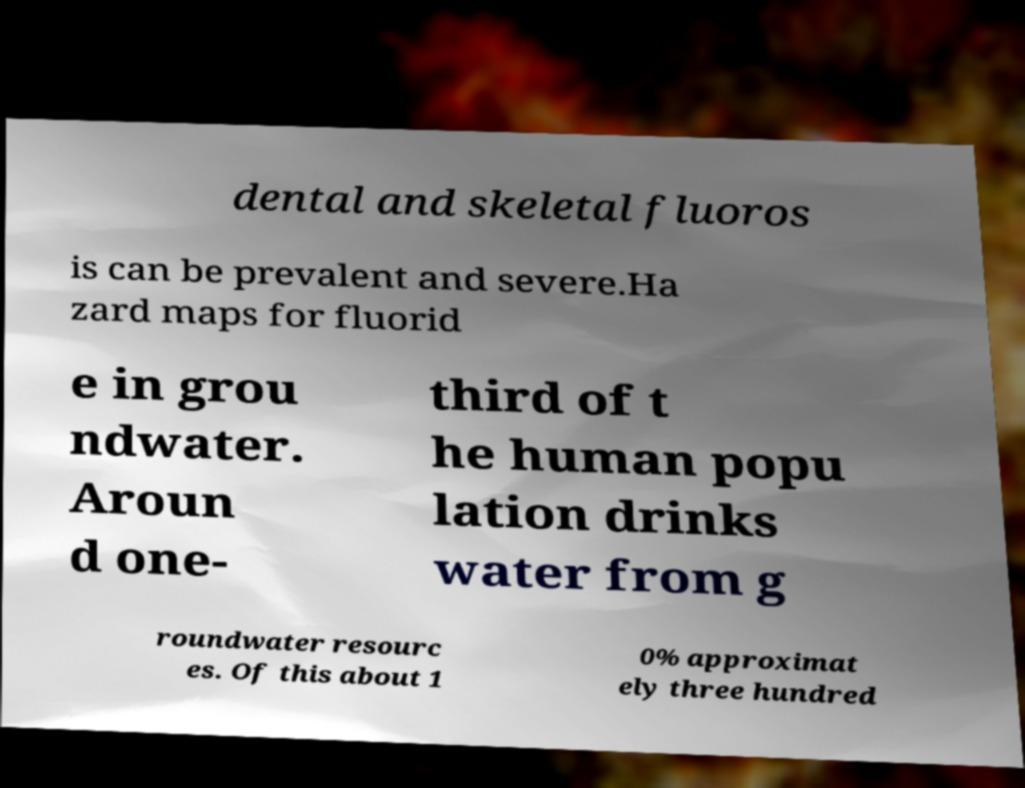What messages or text are displayed in this image? I need them in a readable, typed format. dental and skeletal fluoros is can be prevalent and severe.Ha zard maps for fluorid e in grou ndwater. Aroun d one- third of t he human popu lation drinks water from g roundwater resourc es. Of this about 1 0% approximat ely three hundred 